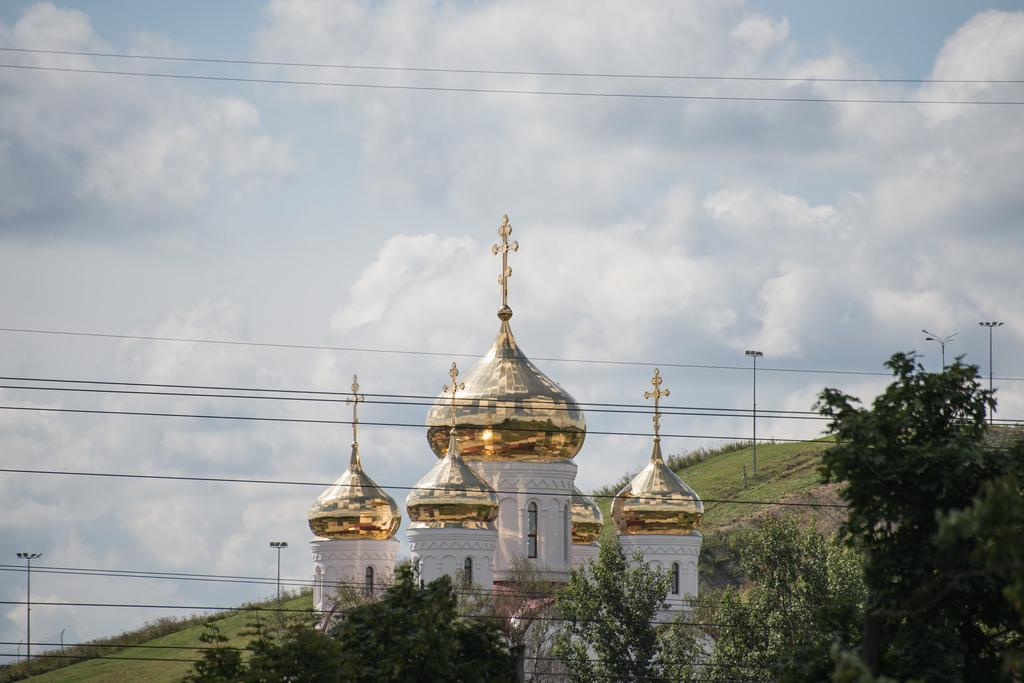What type of vegetation is present in the image? There are trees in the image, and they are green. What can be seen in the background of the image? There is a building in the background of the image, and it is gold and white. What are the light poles used for in the image? The light poles are likely used for illuminating the area at night. What is the color of the sky in the image? The sky is blue and white in the image. What type of disease is affecting the trees in the image? There is no indication of any disease affecting the trees in the image; they appear healthy and green. What type of fork is being used to eat the building in the image? There is no fork present in the image, nor is there any indication that the building is being eaten. 